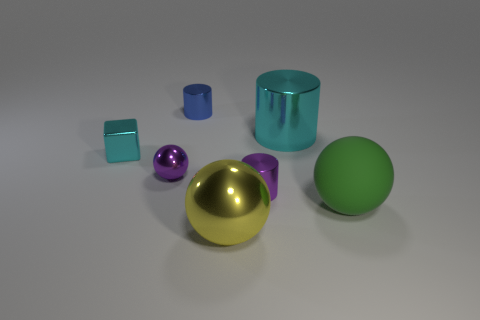Add 2 cyan things. How many objects exist? 9 Subtract all blocks. How many objects are left? 6 Subtract all big blue shiny objects. Subtract all big balls. How many objects are left? 5 Add 1 large cyan shiny things. How many large cyan shiny things are left? 2 Add 4 large cyan cylinders. How many large cyan cylinders exist? 5 Subtract 0 brown blocks. How many objects are left? 7 